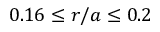Convert formula to latex. <formula><loc_0><loc_0><loc_500><loc_500>0 . 1 6 \leq r / a \leq 0 . 2</formula> 